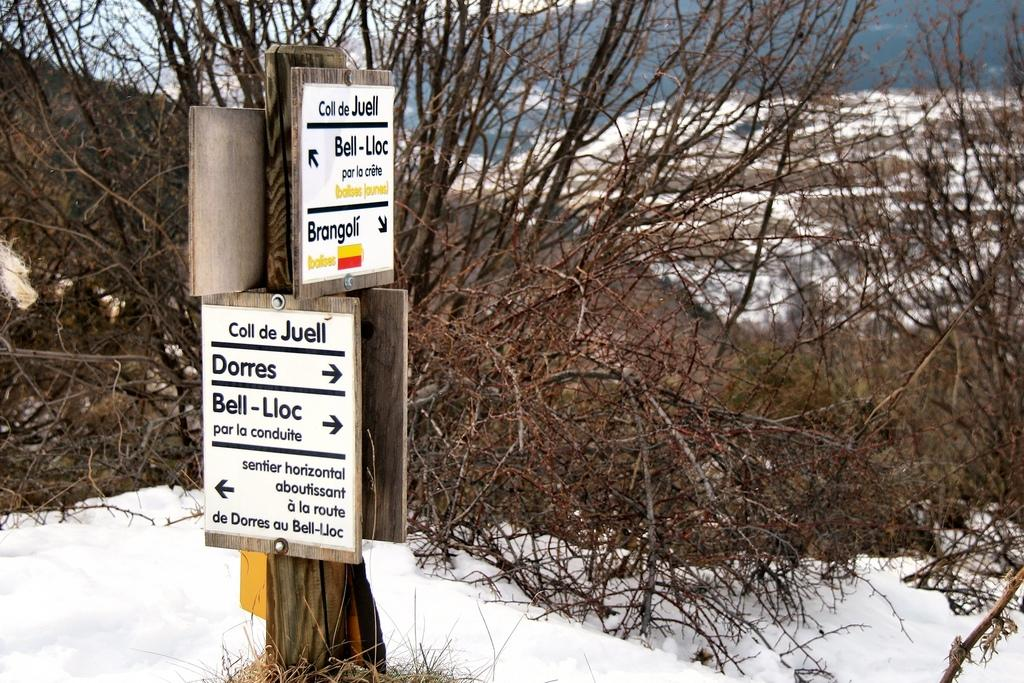What objects are present in the image? There are boards in the image. What can be seen in the background of the image? There are trees in the background of the image. What type of weather is depicted in the image? There is snow at the bottom of the image, indicating a snowy or wintery scene. What type of linen is draped over the boards in the image? There is no linen present in the image; it only features boards and a snowy background. 